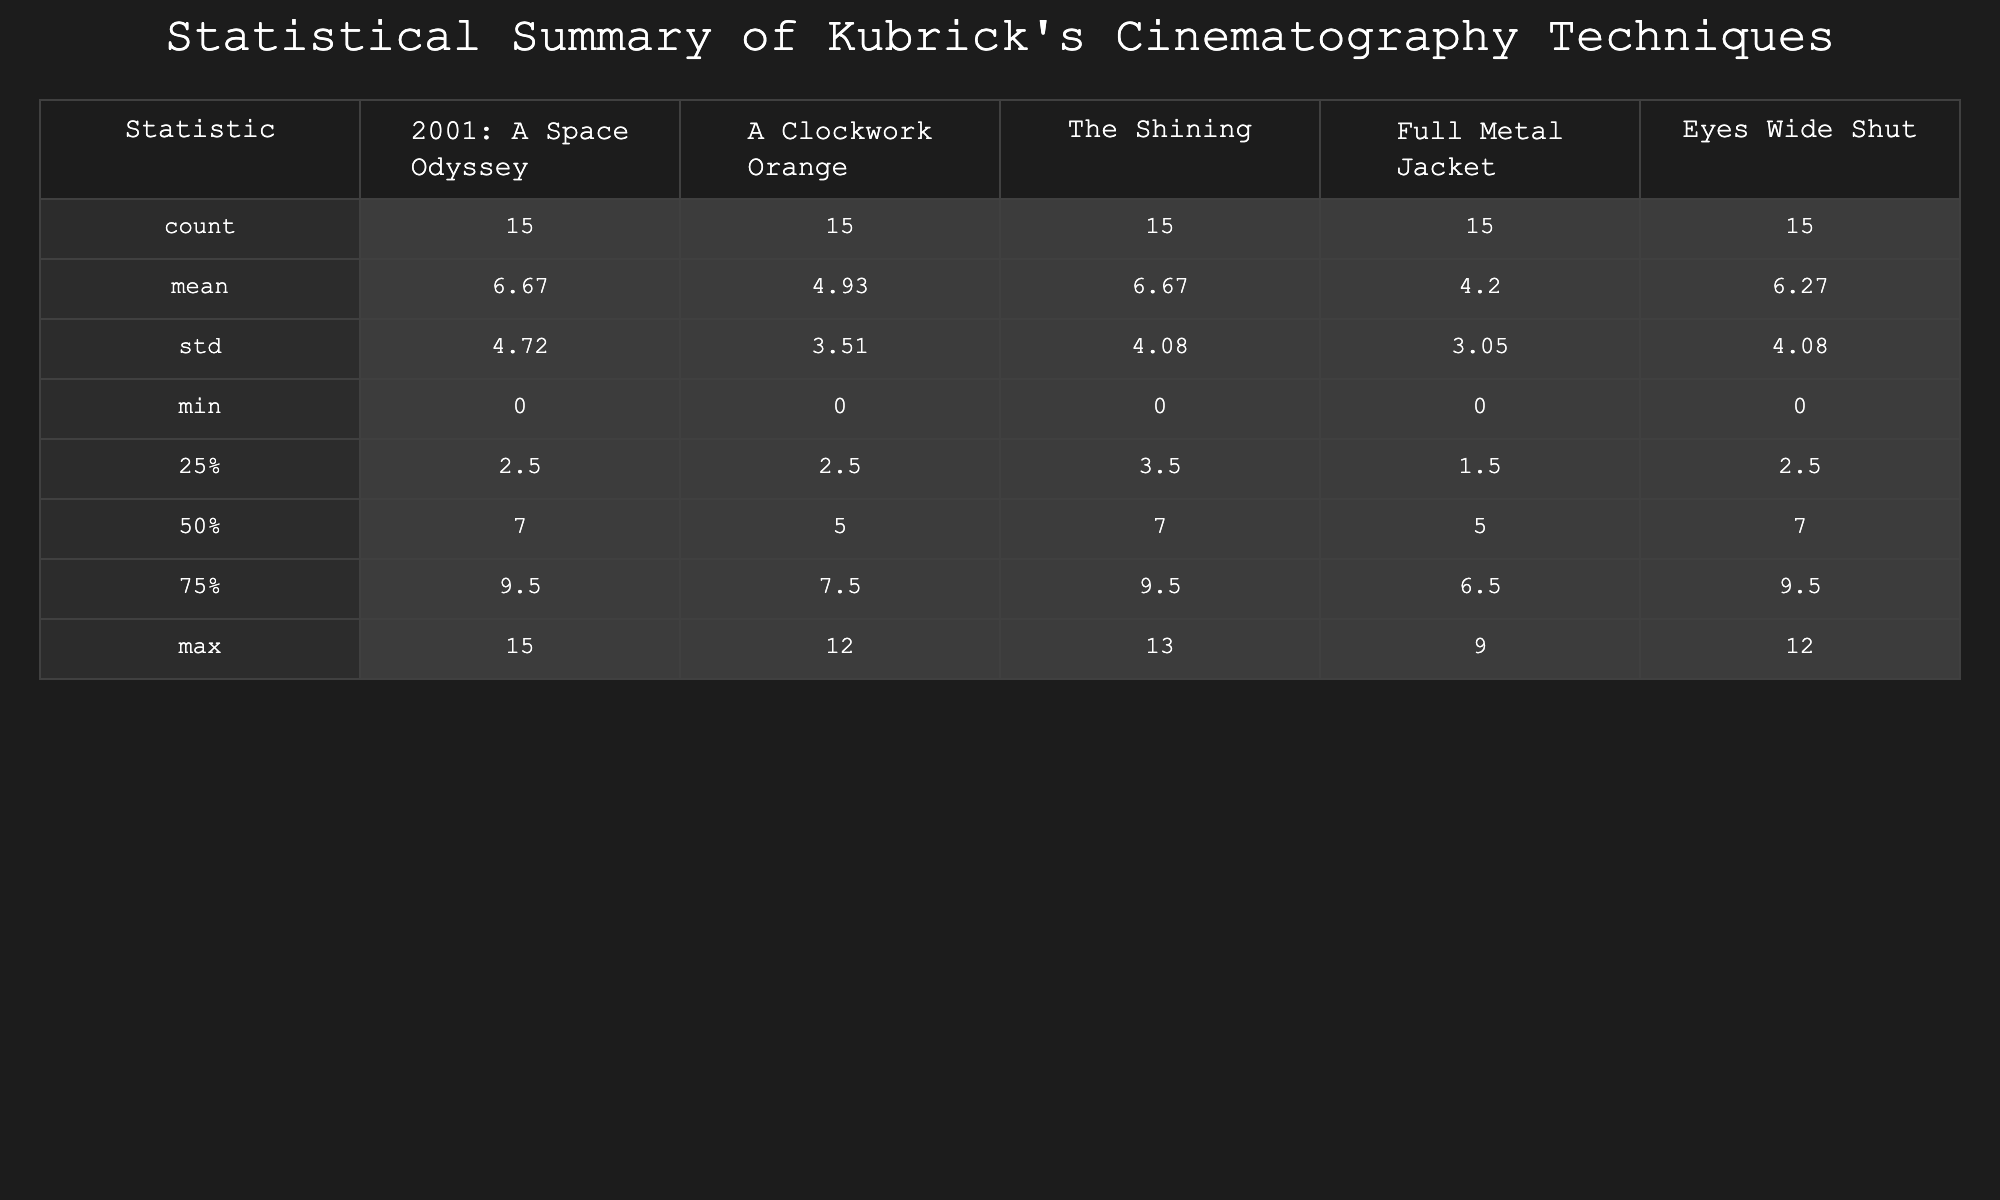What is the highest number of long tracking shots used in Kubrick's films? Looking at the "Long tracking shots" row, the highest value is 9, which is found in "The Shining".
Answer: 9 Which film has the least use of handheld camera techniques? The "Handheld camera" row shows the lowest value is 1 from "The Shining".
Answer: The Shining What is the total number of extreme wide-angle lens uses across all films? By summing the values in the "Extreme wide-angle lenses" row: 10 + 12 + 8 + 5 + 7 = 42.
Answer: 42 What is the average number of candlelit scenes used in Kubrick's films? To find the average, add the values: 0 + 2 + 5 + 0 + 7 = 14, and then divide by 5 (number of films): 14 / 5 = 2.8.
Answer: 2.8 Was natural lighting used more frequently than candlelit scenes in "Eyes Wide Shut"? For "Eyes Wide Shut", natural lighting is 12 and candlelit scenes is 7. Since 12 is greater than 7, the statement is true.
Answer: Yes Which cinematography technique was never used in "2001: A Space Odyssey"? Reviewing the rows, "Steadicam shots" has a value of 0 in "2001: A Space Odyssey".
Answer: Steadicam shots What are the total uses of symmetrical framing across all films? Adding the "Symmetrical framing" values: 14 (2001) + 9 (Clockwork) + 13 (Shining) + 7 (Jacket) + 11 (Eyes) = 54.
Answer: 54 How does the use of slow zooms compare between "A Clockwork Orange" and "Full Metal Jacket"? In "A Clockwork Orange", slow zooms are 6, while in "Full Metal Jacket" they are 3. Since 6 is greater than 3, "A Clockwork Orange" has more.
Answer: A Clockwork Orange Identify the film that used the least number of dolly shots. The "Dolly shots" row indicates that "Full Metal Jacket" had the least usage with a count of 6.
Answer: Full Metal Jacket 